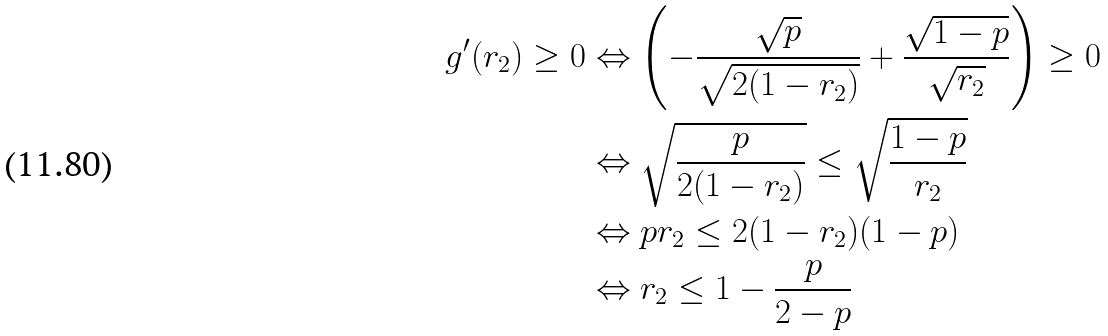Convert formula to latex. <formula><loc_0><loc_0><loc_500><loc_500>g ^ { \prime } ( r _ { 2 } ) \geq 0 & \Leftrightarrow \left ( - \frac { \sqrt { p } } { \sqrt { 2 ( 1 - r _ { 2 } ) } } + \frac { \sqrt { 1 - p } } { { \sqrt { r _ { 2 } } } } \right ) \geq 0 \\ & \Leftrightarrow \sqrt { \frac { p } { 2 ( 1 - r _ { 2 } ) } } \leq \sqrt { \frac { 1 - p } { r _ { 2 } } } \\ & \Leftrightarrow p r _ { 2 } \leq 2 ( 1 - r _ { 2 } ) ( 1 - p ) \\ & \Leftrightarrow r _ { 2 } \leq 1 - \frac { p } { 2 - p }</formula> 